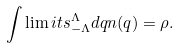<formula> <loc_0><loc_0><loc_500><loc_500>\int \lim i t s _ { - \Lambda } ^ { \Lambda } d q n ( q ) = \rho .</formula> 